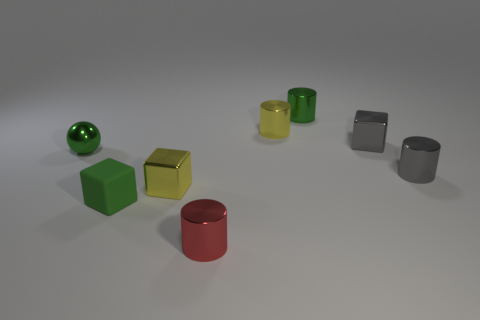There is a cube that is both in front of the small gray metallic cube and right of the tiny green block; what size is it?
Provide a succinct answer. Small. What number of green cylinders are the same size as the green matte block?
Make the answer very short. 1. There is a sphere that is the same color as the matte object; what is its material?
Your response must be concise. Metal. Do the green thing that is right of the small green cube and the tiny red thing have the same shape?
Offer a very short reply. Yes. Are there fewer things right of the green cube than big brown spheres?
Keep it short and to the point. No. Are there any matte blocks that have the same color as the matte object?
Your response must be concise. No. There is a matte thing; does it have the same shape as the tiny gray shiny object on the right side of the gray shiny block?
Give a very brief answer. No. Are there any other red things that have the same material as the red thing?
Make the answer very short. No. Are there any metal things that are right of the green metallic thing to the right of the metallic cylinder in front of the matte object?
Your answer should be compact. Yes. What number of other objects are there of the same shape as the red object?
Offer a very short reply. 3. 